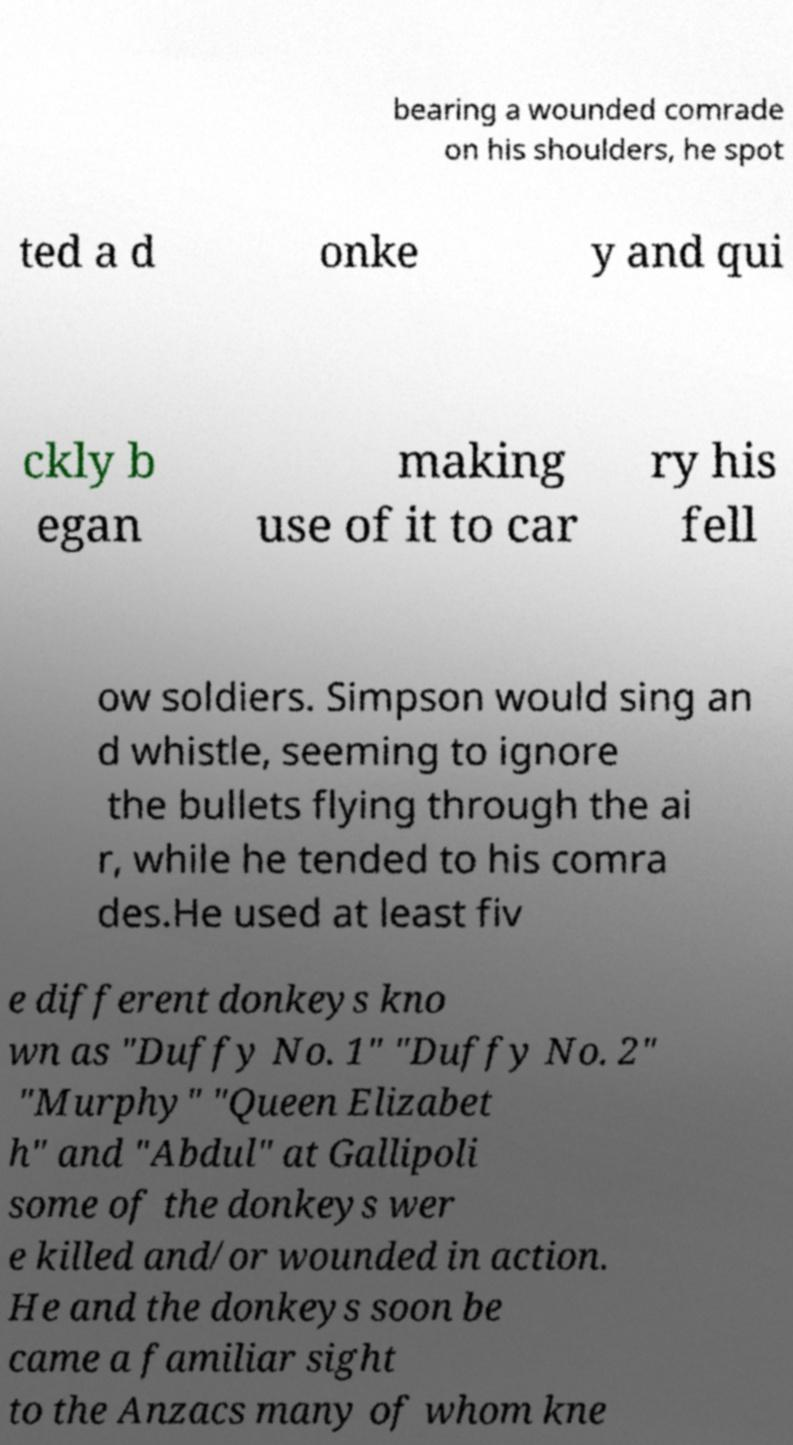Please read and relay the text visible in this image. What does it say? bearing a wounded comrade on his shoulders, he spot ted a d onke y and qui ckly b egan making use of it to car ry his fell ow soldiers. Simpson would sing an d whistle, seeming to ignore the bullets flying through the ai r, while he tended to his comra des.He used at least fiv e different donkeys kno wn as "Duffy No. 1" "Duffy No. 2" "Murphy" "Queen Elizabet h" and "Abdul" at Gallipoli some of the donkeys wer e killed and/or wounded in action. He and the donkeys soon be came a familiar sight to the Anzacs many of whom kne 